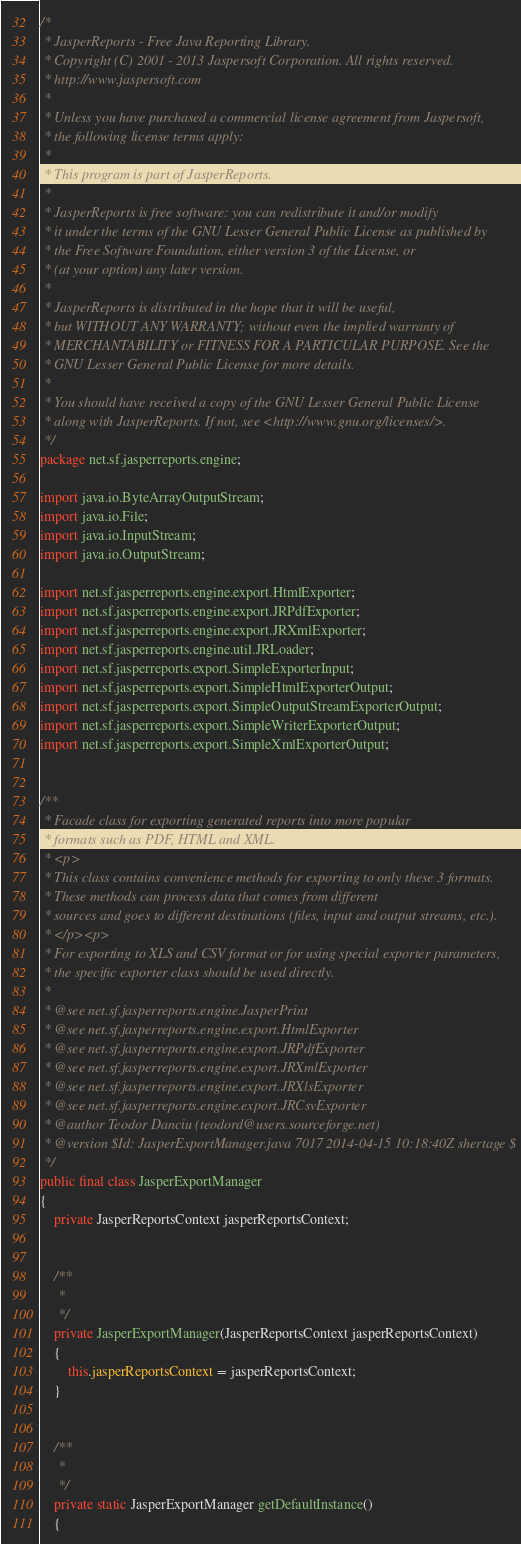Convert code to text. <code><loc_0><loc_0><loc_500><loc_500><_Java_>/*
 * JasperReports - Free Java Reporting Library.
 * Copyright (C) 2001 - 2013 Jaspersoft Corporation. All rights reserved.
 * http://www.jaspersoft.com
 *
 * Unless you have purchased a commercial license agreement from Jaspersoft,
 * the following license terms apply:
 *
 * This program is part of JasperReports.
 *
 * JasperReports is free software: you can redistribute it and/or modify
 * it under the terms of the GNU Lesser General Public License as published by
 * the Free Software Foundation, either version 3 of the License, or
 * (at your option) any later version.
 *
 * JasperReports is distributed in the hope that it will be useful,
 * but WITHOUT ANY WARRANTY; without even the implied warranty of
 * MERCHANTABILITY or FITNESS FOR A PARTICULAR PURPOSE. See the
 * GNU Lesser General Public License for more details.
 *
 * You should have received a copy of the GNU Lesser General Public License
 * along with JasperReports. If not, see <http://www.gnu.org/licenses/>.
 */
package net.sf.jasperreports.engine;

import java.io.ByteArrayOutputStream;
import java.io.File;
import java.io.InputStream;
import java.io.OutputStream;

import net.sf.jasperreports.engine.export.HtmlExporter;
import net.sf.jasperreports.engine.export.JRPdfExporter;
import net.sf.jasperreports.engine.export.JRXmlExporter;
import net.sf.jasperreports.engine.util.JRLoader;
import net.sf.jasperreports.export.SimpleExporterInput;
import net.sf.jasperreports.export.SimpleHtmlExporterOutput;
import net.sf.jasperreports.export.SimpleOutputStreamExporterOutput;
import net.sf.jasperreports.export.SimpleWriterExporterOutput;
import net.sf.jasperreports.export.SimpleXmlExporterOutput;


/**
 * Facade class for exporting generated reports into more popular
 * formats such as PDF, HTML and XML.
 * <p>
 * This class contains convenience methods for exporting to only these 3 formats.
 * These methods can process data that comes from different
 * sources and goes to different destinations (files, input and output streams, etc.).
 * </p><p>
 * For exporting to XLS and CSV format or for using special exporter parameters, 
 * the specific exporter class should be used directly.  
 * 
 * @see net.sf.jasperreports.engine.JasperPrint
 * @see net.sf.jasperreports.engine.export.HtmlExporter
 * @see net.sf.jasperreports.engine.export.JRPdfExporter
 * @see net.sf.jasperreports.engine.export.JRXmlExporter
 * @see net.sf.jasperreports.engine.export.JRXlsExporter
 * @see net.sf.jasperreports.engine.export.JRCsvExporter
 * @author Teodor Danciu (teodord@users.sourceforge.net)
 * @version $Id: JasperExportManager.java 7017 2014-04-15 10:18:40Z shertage $
 */
public final class JasperExportManager
{
	private JasperReportsContext jasperReportsContext;


	/**
	 *
	 */
	private JasperExportManager(JasperReportsContext jasperReportsContext)
	{
		this.jasperReportsContext = jasperReportsContext;
	}
	
	
	/**
	 *
	 */
	private static JasperExportManager getDefaultInstance()
	{</code> 